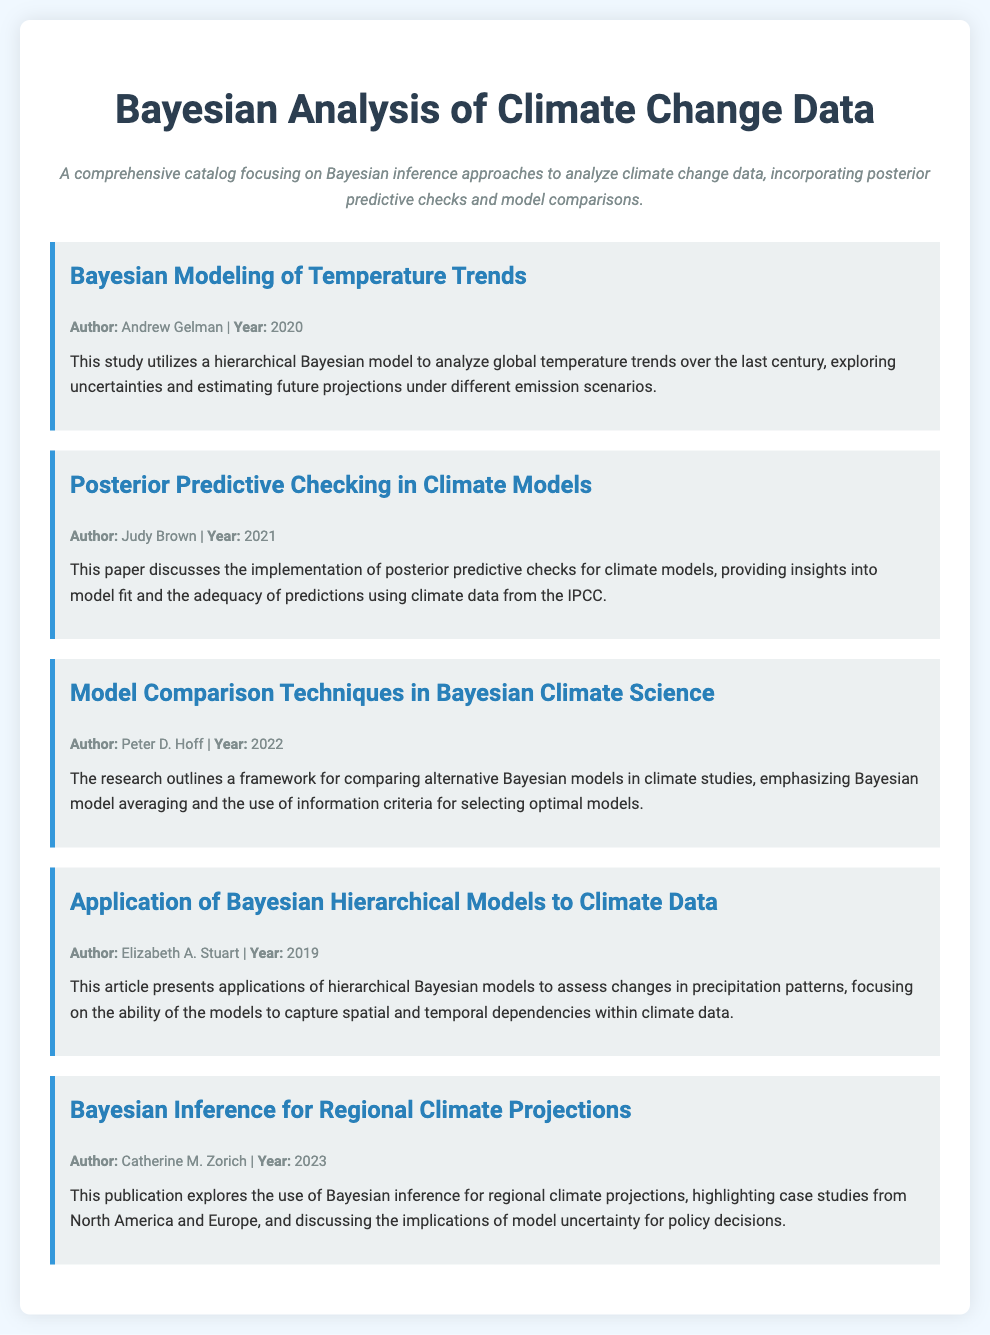What is the title of the catalog? The title of the catalog is prominently displayed at the top of the document.
Answer: Bayesian Analysis of Climate Change Data Who is the author of the "Bayesian Modeling of Temperature Trends" study? The author's name is provided in the material section for each study.
Answer: Andrew Gelman What year was the "Posterior Predictive Checking in Climate Models" paper published? The publication year is listed alongside the author's name in the material information.
Answer: 2021 What framework is outlined in the "Model Comparison Techniques in Bayesian Climate Science"? The document summarizes the main topic or framework discussed in each section.
Answer: Comparing alternative Bayesian models Which author published a study in 2023? The year is listed in the material information, specifying which study corresponds to that year.
Answer: Catherine M. Zorich What type of models does Elizabeth A. Stuart discuss in her article? The document describes the focus of her article in the material summary.
Answer: Hierarchical Bayesian models What is the main topic of Catherine M. Zorich's publication? The main topic is mentioned in the summary of the corresponding material.
Answer: Regional climate projections In which year was the research on climate data by Elizabeth A. Stuart published? The year of publication is stated in the material information.
Answer: 2019 